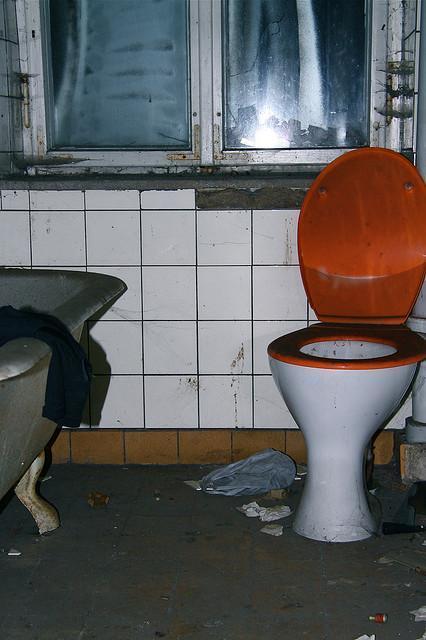How many sinks are there?
Give a very brief answer. 1. How many paws does the cat have in the toilet?
Give a very brief answer. 0. 